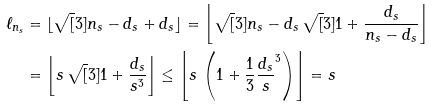Convert formula to latex. <formula><loc_0><loc_0><loc_500><loc_500>\ell _ { n _ { s } } & = \lfloor \sqrt { [ } 3 ] { n _ { s } - d _ { s } + d _ { s } } \rfloor = \left \lfloor \sqrt { [ } 3 ] { n _ { s } - d _ { s } } \, \sqrt { [ } 3 ] { 1 + \frac { d _ { s } } { n _ { s } - d _ { s } } } \right \rfloor \\ & = \left \lfloor s \, \sqrt { [ } 3 ] { 1 + \frac { d _ { s } } { s ^ { 3 } } } \right \rfloor \leq \left \lfloor s \, \left ( 1 + \frac { 1 } { 3 } \frac { d _ { s } } s ^ { 3 } \right ) \right \rfloor = s</formula> 